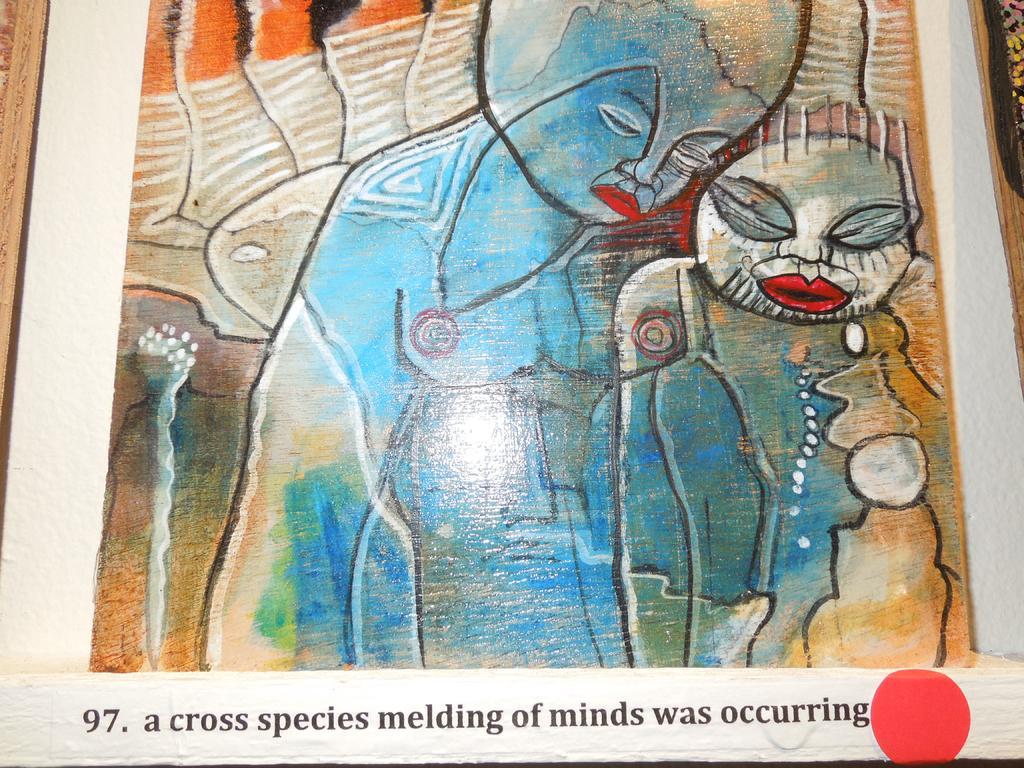Can you describe this image briefly? In this image I can see a painting of two persons standing which is blue, red, orange, cream, green and brown in color. I can see few words written with black color to the bottom of the image. 